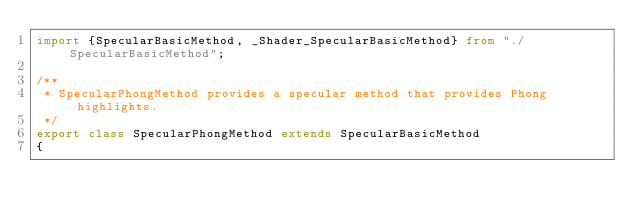Convert code to text. <code><loc_0><loc_0><loc_500><loc_500><_TypeScript_>import {SpecularBasicMethod, _Shader_SpecularBasicMethod} from "./SpecularBasicMethod";

/**
 * SpecularPhongMethod provides a specular method that provides Phong highlights.
 */
export class SpecularPhongMethod extends SpecularBasicMethod
{</code> 